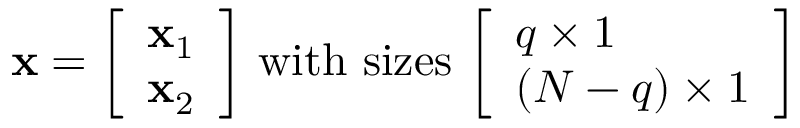Convert formula to latex. <formula><loc_0><loc_0><loc_500><loc_500>x = { \left [ \begin{array} { l } { x _ { 1 } } \\ { x _ { 2 } } \end{array} \right ] } { w i t h s i z e s } { \left [ \begin{array} { l } { q \times 1 } \\ { ( N - q ) \times 1 } \end{array} \right ] }</formula> 